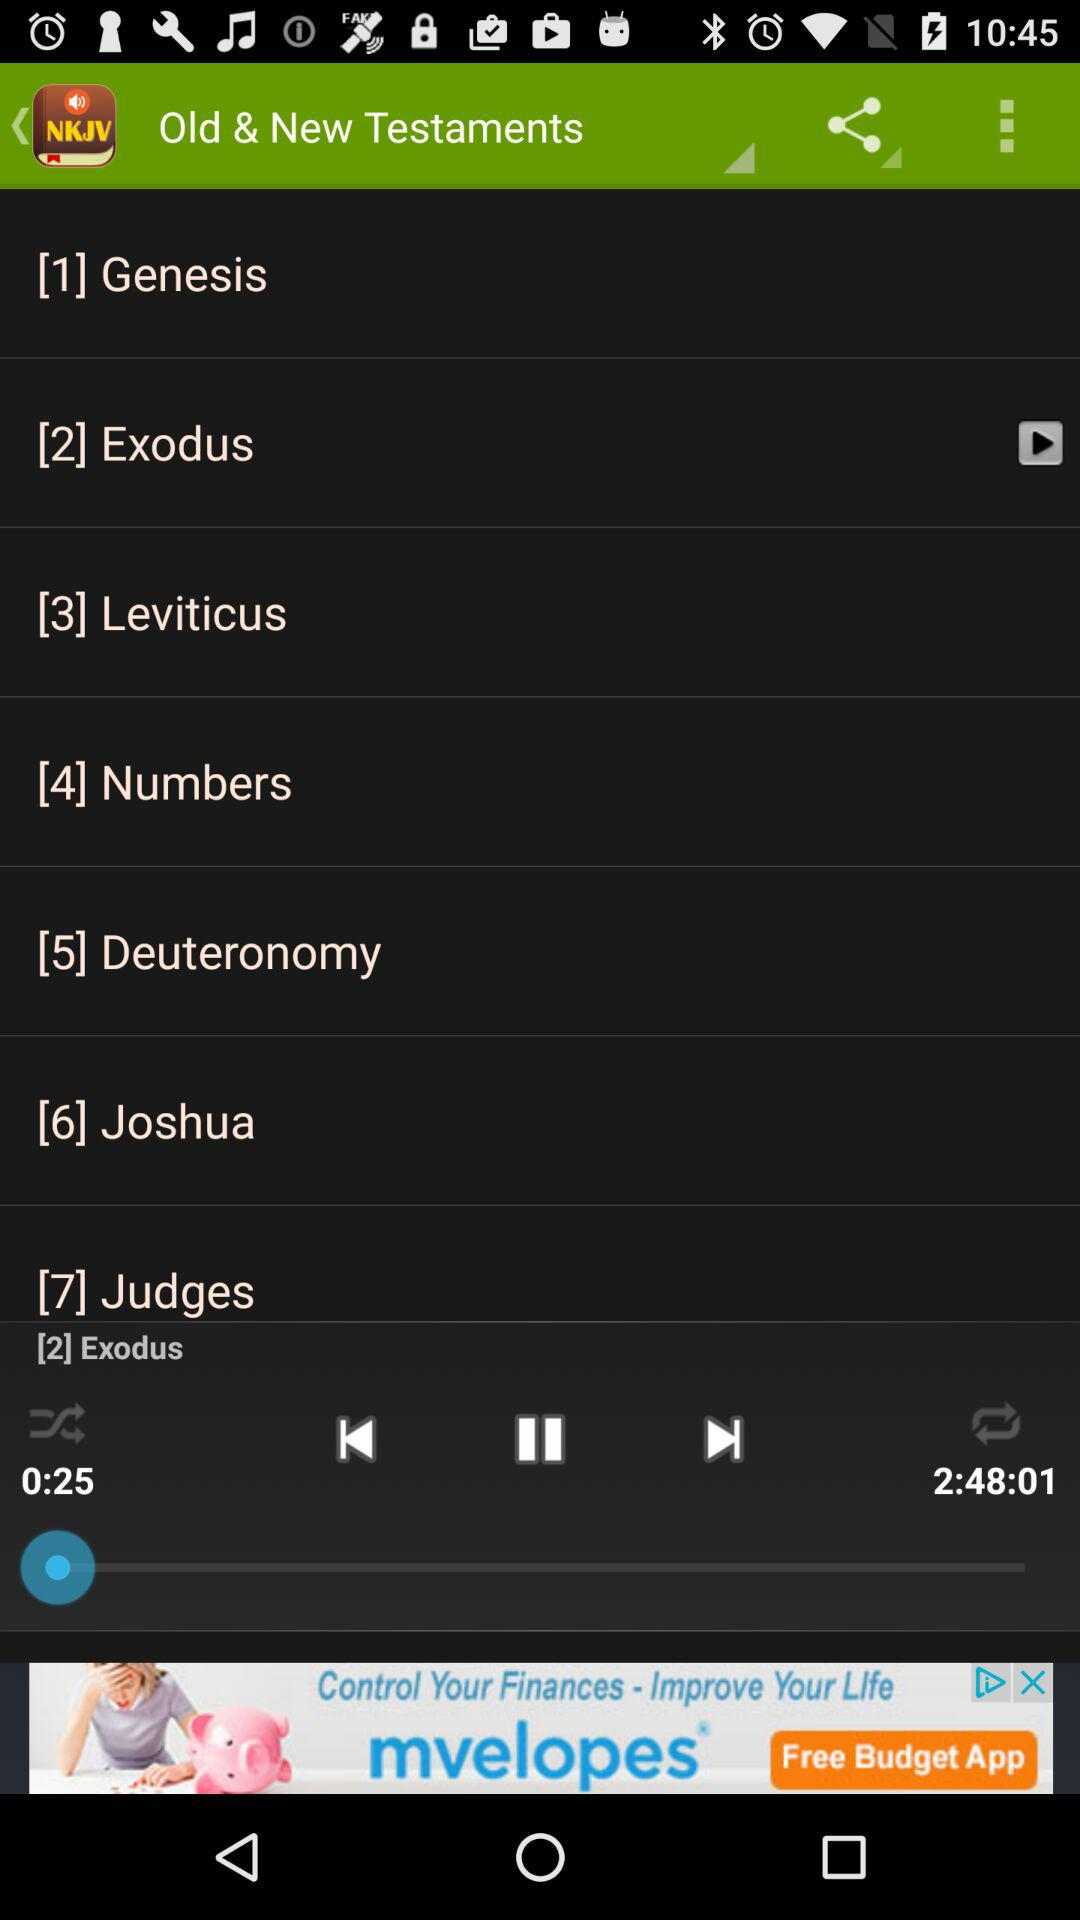What is the number of Jugdes present?
When the provided information is insufficient, respond with <no answer>. <no answer> 